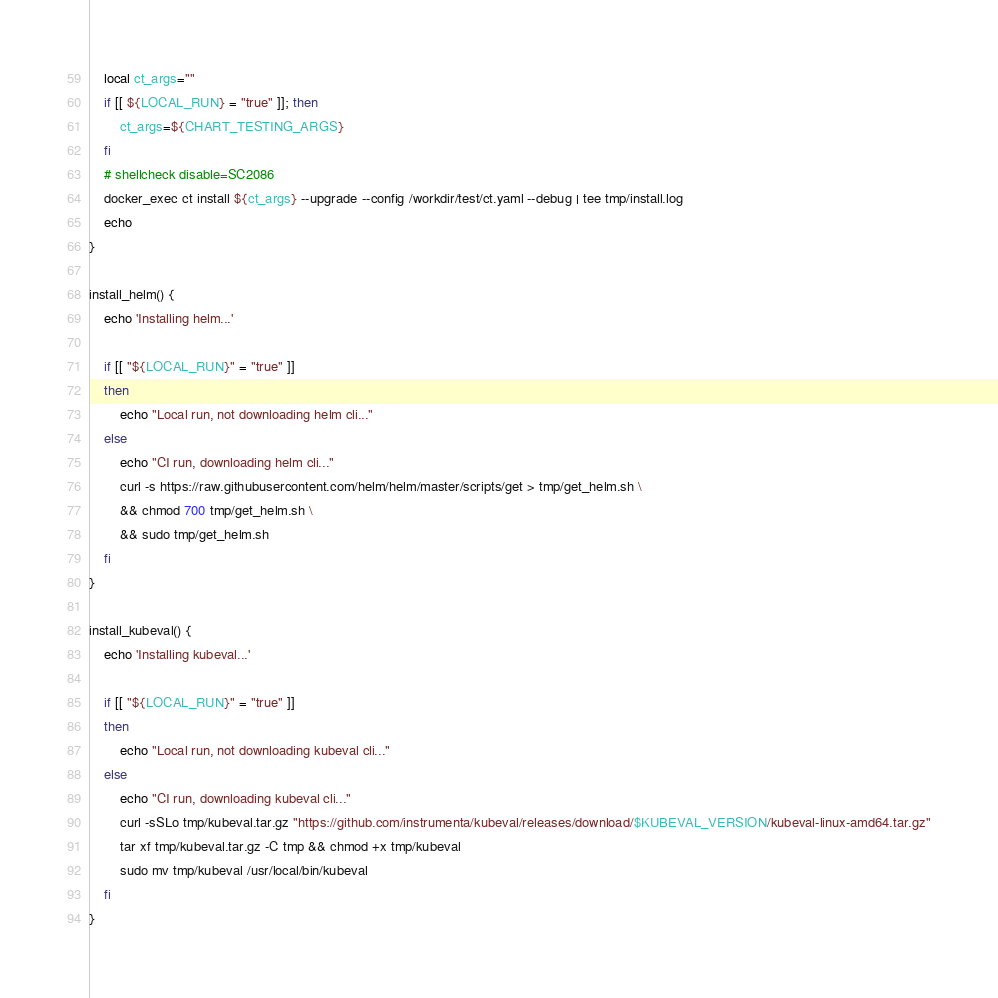<code> <loc_0><loc_0><loc_500><loc_500><_Bash_>    local ct_args=""
    if [[ ${LOCAL_RUN} = "true" ]]; then
        ct_args=${CHART_TESTING_ARGS}
    fi
    # shellcheck disable=SC2086
    docker_exec ct install ${ct_args} --upgrade --config /workdir/test/ct.yaml --debug | tee tmp/install.log
    echo
}

install_helm() {
    echo 'Installing helm...'

    if [[ "${LOCAL_RUN}" = "true" ]]
    then
        echo "Local run, not downloading helm cli..."
    else
        echo "CI run, downloading helm cli..."
        curl -s https://raw.githubusercontent.com/helm/helm/master/scripts/get > tmp/get_helm.sh \
        && chmod 700 tmp/get_helm.sh \
        && sudo tmp/get_helm.sh
    fi
}

install_kubeval() {
    echo 'Installing kubeval...'

    if [[ "${LOCAL_RUN}" = "true" ]]
    then
        echo "Local run, not downloading kubeval cli..."
    else
        echo "CI run, downloading kubeval cli..."
        curl -sSLo tmp/kubeval.tar.gz "https://github.com/instrumenta/kubeval/releases/download/$KUBEVAL_VERSION/kubeval-linux-amd64.tar.gz"
        tar xf tmp/kubeval.tar.gz -C tmp && chmod +x tmp/kubeval
        sudo mv tmp/kubeval /usr/local/bin/kubeval
    fi
}
</code> 